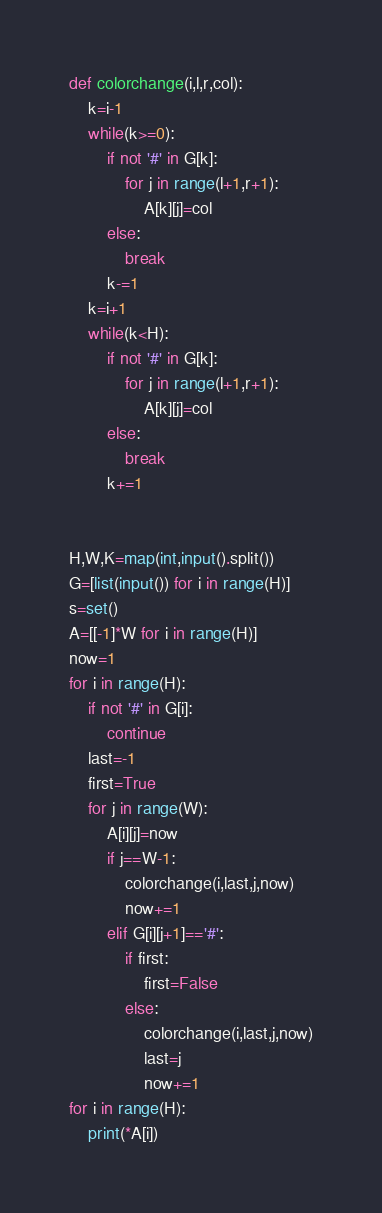Convert code to text. <code><loc_0><loc_0><loc_500><loc_500><_Python_>def colorchange(i,l,r,col):
    k=i-1
    while(k>=0):
        if not '#' in G[k]:
            for j in range(l+1,r+1):
                A[k][j]=col
        else:
            break
        k-=1
    k=i+1
    while(k<H):
        if not '#' in G[k]:
            for j in range(l+1,r+1):
                A[k][j]=col
        else:
            break
        k+=1
        

H,W,K=map(int,input().split())
G=[list(input()) for i in range(H)]
s=set()
A=[[-1]*W for i in range(H)]
now=1
for i in range(H):
    if not '#' in G[i]:
        continue
    last=-1
    first=True
    for j in range(W):
        A[i][j]=now
        if j==W-1:
            colorchange(i,last,j,now)
            now+=1
        elif G[i][j+1]=='#':
            if first:
                first=False
            else:
                colorchange(i,last,j,now)
                last=j
                now+=1
for i in range(H):
    print(*A[i])</code> 